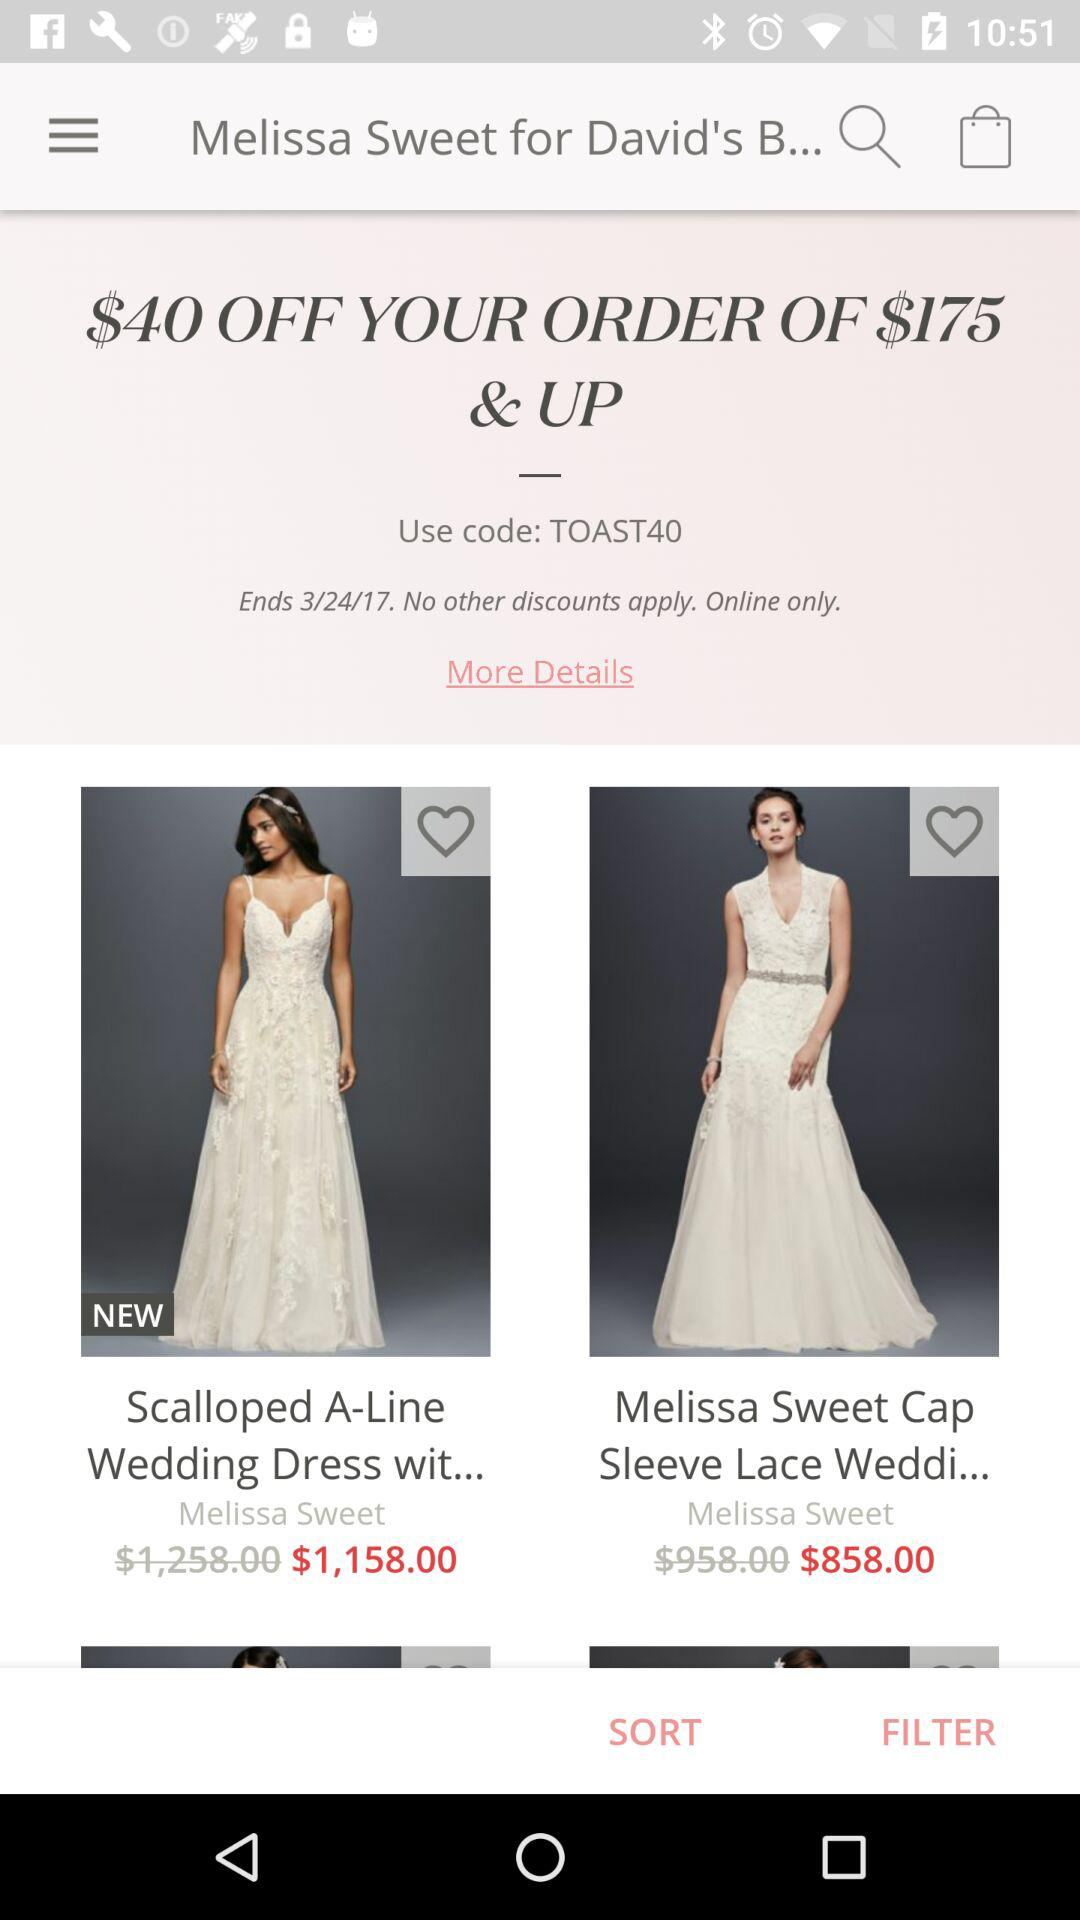What is the code for "$40 OFF"? The code for "$40 OFF" is "TOAST40". 